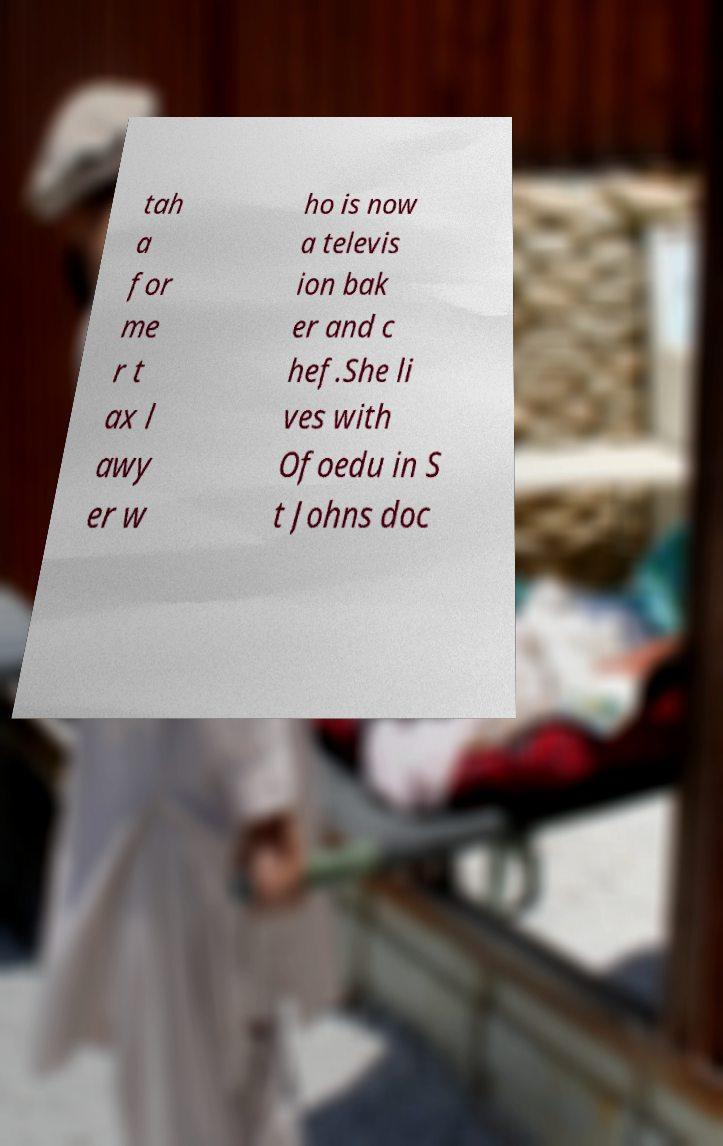Can you accurately transcribe the text from the provided image for me? tah a for me r t ax l awy er w ho is now a televis ion bak er and c hef.She li ves with Ofoedu in S t Johns doc 